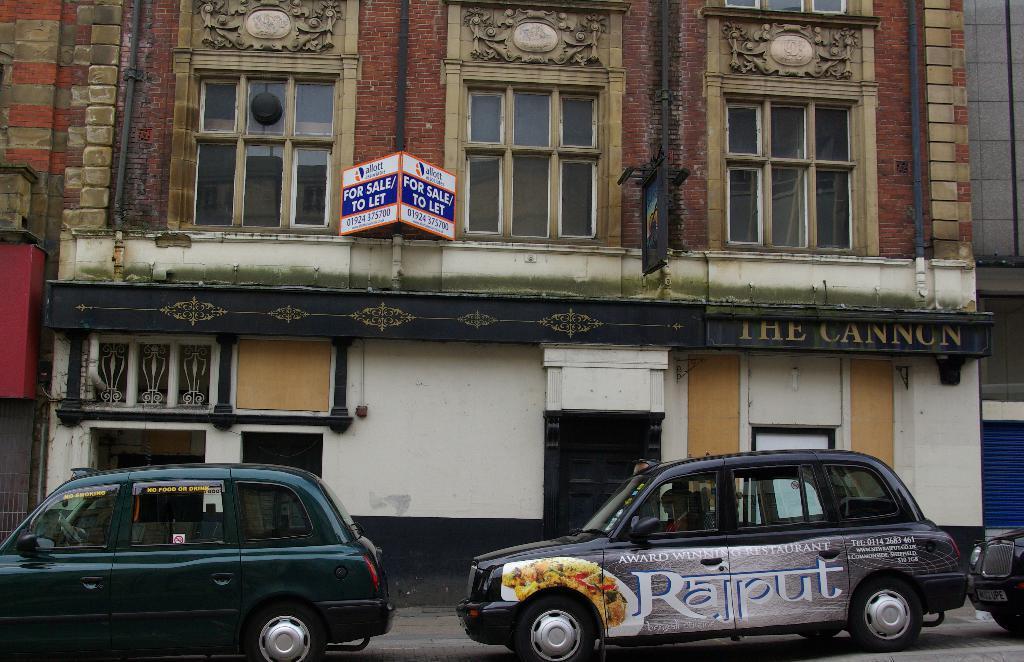Could you give a brief overview of what you see in this image? In the picture we can see a building with some windows and glasses to it and near to it, we can see some cars are parked and the name of the building is the cannon. 